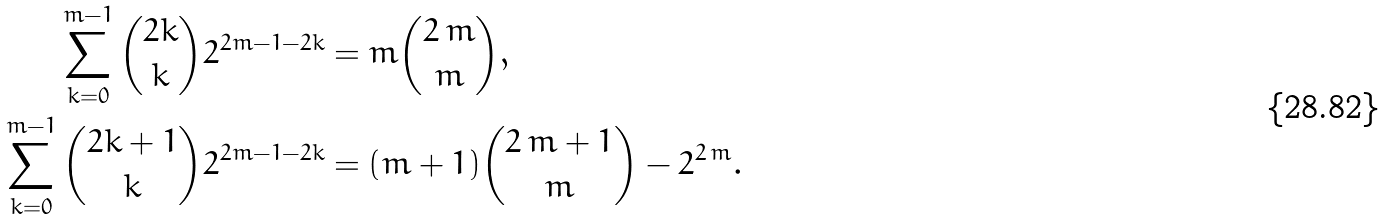Convert formula to latex. <formula><loc_0><loc_0><loc_500><loc_500>\sum _ { k = 0 } ^ { m - 1 } { 2 k \choose k } 2 ^ { 2 m - 1 - 2 k } & = m { 2 \, m \choose m } , \\ \sum _ { k = 0 } ^ { m - 1 } { 2 k + 1 \choose k } 2 ^ { 2 m - 1 - 2 k } & = ( m + 1 ) { 2 \, m + 1 \choose m } - { 2 } ^ { 2 \, m } .</formula> 